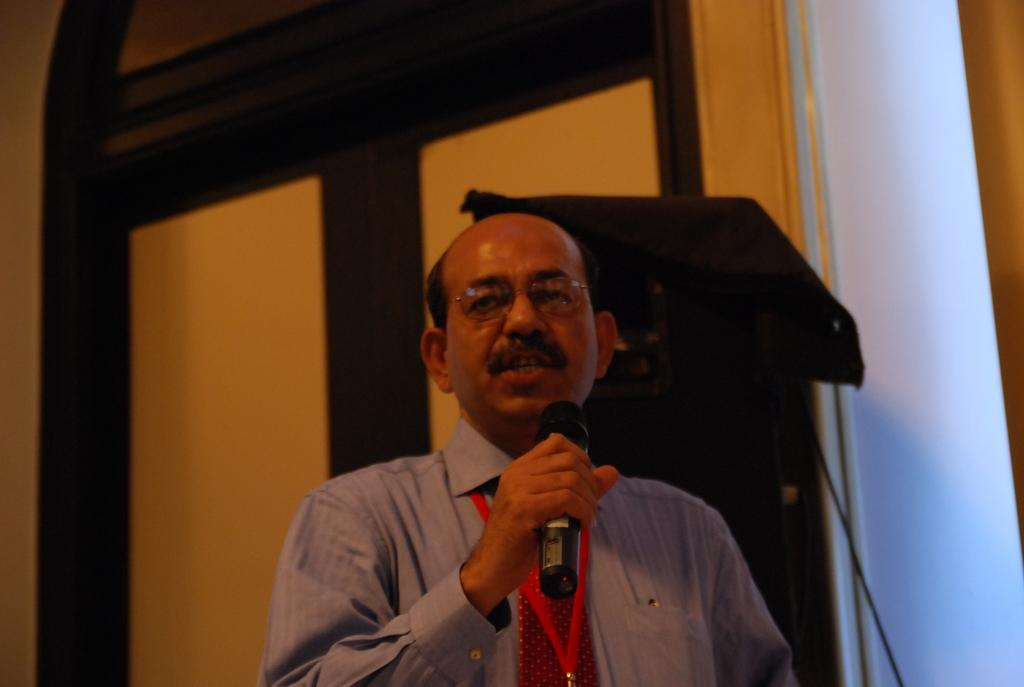What is the main subject of the image? There is a person in the image. What is the person holding in his hands? The person is holding a microphone in his hands. Can you describe any accessories the person is wearing? The person is wearing an ID card and glasses (specs). What type of wing can be seen on the person in the image? There is no wing visible on the person in the image. What cause does the person in the image support? The image does not provide information about the person's cause or beliefs. 